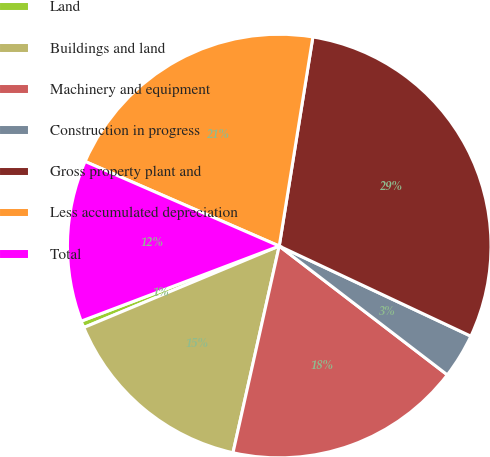<chart> <loc_0><loc_0><loc_500><loc_500><pie_chart><fcel>Land<fcel>Buildings and land<fcel>Machinery and equipment<fcel>Construction in progress<fcel>Gross property plant and<fcel>Less accumulated depreciation<fcel>Total<nl><fcel>0.52%<fcel>15.21%<fcel>18.1%<fcel>3.41%<fcel>29.46%<fcel>21.0%<fcel>12.31%<nl></chart> 